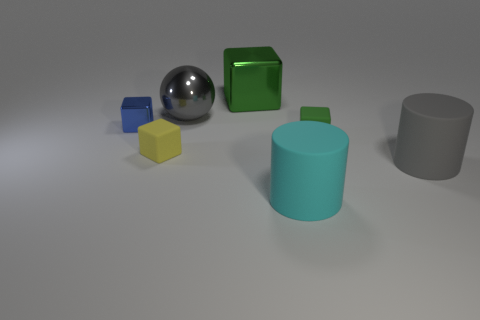Subtract all green metal cubes. How many cubes are left? 3 Subtract all brown balls. How many green cubes are left? 2 Add 2 gray rubber cylinders. How many objects exist? 9 Subtract 2 blocks. How many blocks are left? 2 Subtract all blue cubes. How many cubes are left? 3 Subtract all blocks. How many objects are left? 3 Subtract all yellow blocks. Subtract all purple cylinders. How many blocks are left? 3 Subtract all large brown metallic cylinders. Subtract all big cyan rubber objects. How many objects are left? 6 Add 7 big metal balls. How many big metal balls are left? 8 Add 4 big gray matte balls. How many big gray matte balls exist? 4 